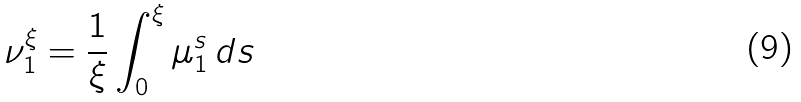Convert formula to latex. <formula><loc_0><loc_0><loc_500><loc_500>\nu _ { 1 } ^ { \xi } = \frac { 1 } { \xi } \int _ { 0 } ^ { \xi } \mu _ { 1 } ^ { s } \, d s</formula> 